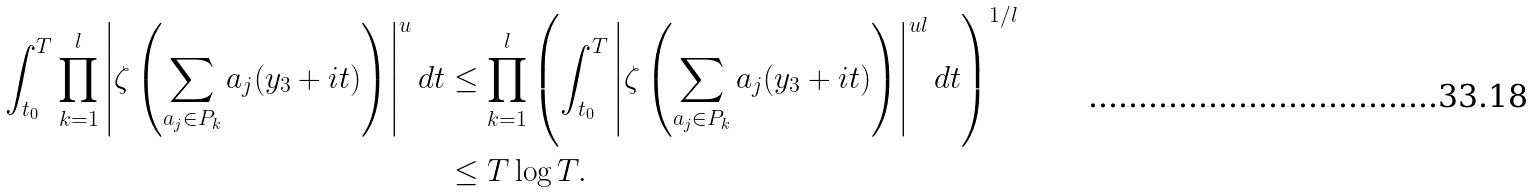Convert formula to latex. <formula><loc_0><loc_0><loc_500><loc_500>\int _ { t _ { 0 } } ^ { T } \prod _ { k = 1 } ^ { l } \left | \zeta \left ( \sum _ { a _ { j } \in P _ { k } } a _ { j } ( y _ { 3 } + i t ) \right ) \right | ^ { u } d t & \leq \prod _ { k = 1 } ^ { l } \left ( \int _ { t _ { 0 } } ^ { T } \left | \zeta \left ( \sum _ { a _ { j } \in P _ { k } } a _ { j } ( y _ { 3 } + i t ) \right ) \right | ^ { u l } d t \right ) ^ { 1 / l } \\ & \leq T \log T .</formula> 